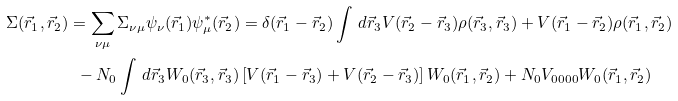Convert formula to latex. <formula><loc_0><loc_0><loc_500><loc_500>\Sigma ( \vec { r } _ { 1 } , \vec { r } _ { 2 } ) & = \sum _ { \nu \mu } \Sigma _ { \nu \mu } \psi _ { \nu } ( \vec { r } _ { 1 } ) \psi ^ { * } _ { \mu } ( \vec { r } _ { 2 } ) = \delta ( \vec { r } _ { 1 } - \vec { r } _ { 2 } ) \int \, d \vec { r } _ { 3 } V ( \vec { r } _ { 2 } - \vec { r } _ { 3 } ) \rho ( \vec { r } _ { 3 } , \vec { r } _ { 3 } ) + V ( \vec { r } _ { 1 } - \vec { r } _ { 2 } ) \rho ( \vec { r } _ { 1 } , \vec { r } _ { 2 } ) \\ & \ \ - N _ { 0 } \int \, d \vec { r } _ { 3 } W _ { 0 } ( \vec { r } _ { 3 } , \vec { r } _ { 3 } ) \left [ V ( \vec { r } _ { 1 } - \vec { r } _ { 3 } ) + V ( \vec { r } _ { 2 } - \vec { r } _ { 3 } ) \right ] W _ { 0 } ( \vec { r } _ { 1 } , \vec { r } _ { 2 } ) + N _ { 0 } V _ { 0 0 0 0 } W _ { 0 } ( \vec { r } _ { 1 } , \vec { r } _ { 2 } )</formula> 